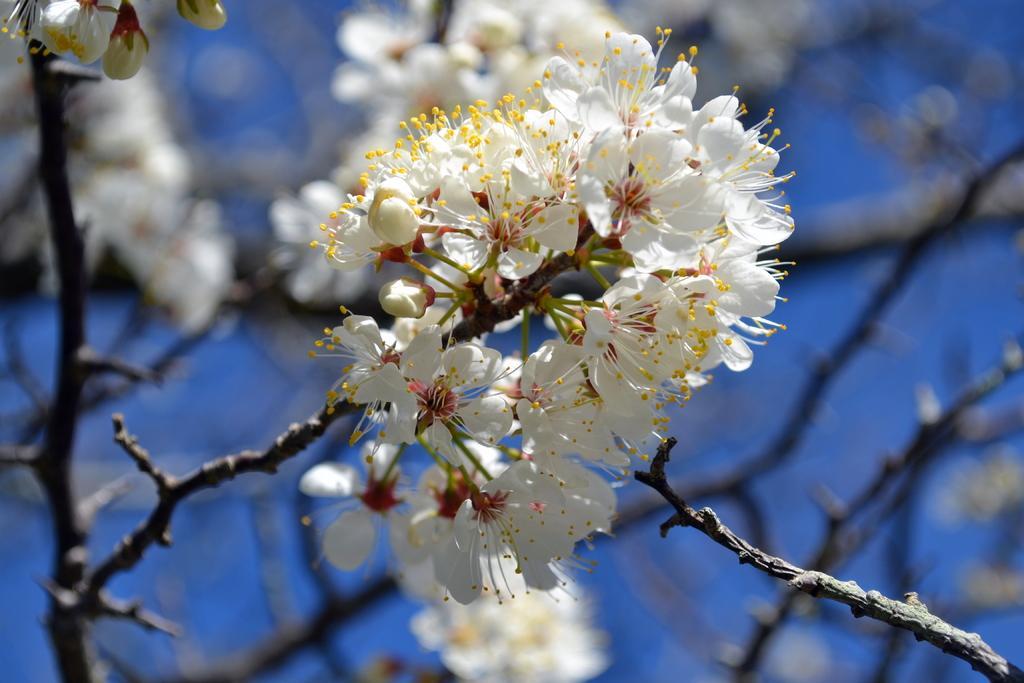Can you describe this image briefly? There are beautiful white flowers to the branch of a tree. 